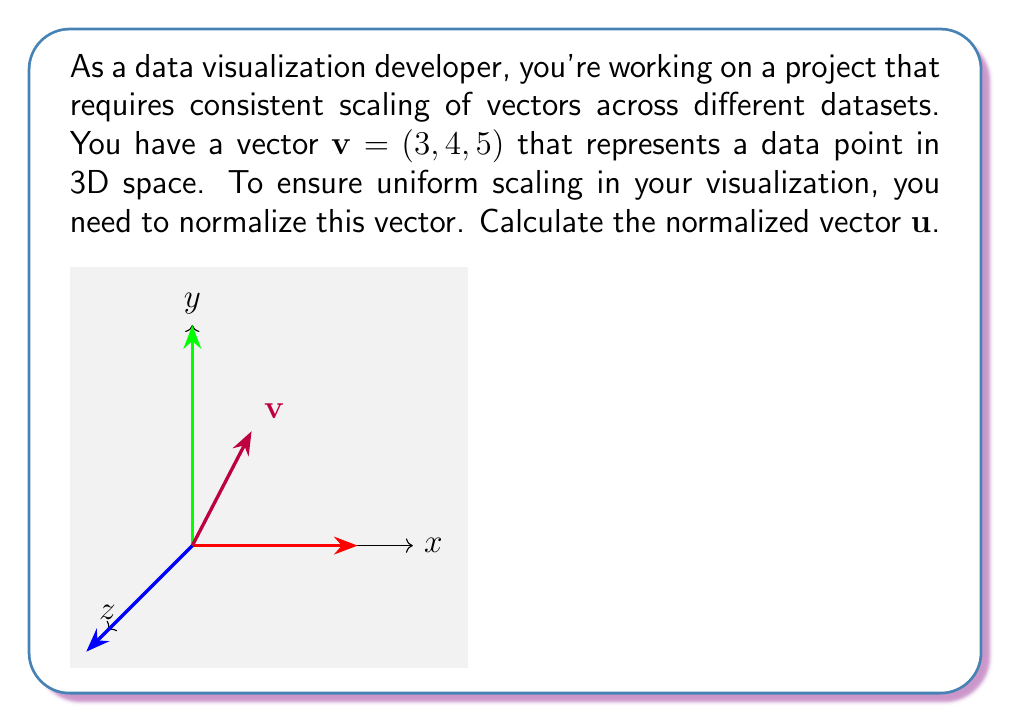Show me your answer to this math problem. To normalize a vector, we need to divide it by its magnitude. Let's break this down step-by-step:

1) First, calculate the magnitude of the vector $\mathbf{v}$. The magnitude is given by the square root of the sum of the squares of its components:

   $$\|\mathbf{v}\| = \sqrt{3^2 + 4^2 + 5^2}$$

2) Simplify:
   $$\|\mathbf{v}\| = \sqrt{9 + 16 + 25} = \sqrt{50}$$

3) The normalized vector $\mathbf{u}$ is obtained by dividing each component of $\mathbf{v}$ by the magnitude:

   $$\mathbf{u} = \frac{\mathbf{v}}{\|\mathbf{v}\|} = \left(\frac{3}{\sqrt{50}}, \frac{4}{\sqrt{50}}, \frac{5}{\sqrt{50}}\right)$$

4) Simplify by factoring out $\frac{1}{\sqrt{50}}$:

   $$\mathbf{u} = \frac{1}{\sqrt{50}}(3, 4, 5)$$

5) To simplify further, we can rationalize the denominator:

   $$\mathbf{u} = \frac{1}{\sqrt{50}} \cdot \frac{\sqrt{50}}{\sqrt{50}}(3, 4, 5) = \frac{\sqrt{50}}{50}(3, 4, 5)$$

6) Simplify:

   $$\mathbf{u} = \frac{\sqrt{2}}{10}(3, 4, 5)$$

This normalized vector $\mathbf{u}$ has a magnitude of 1, which ensures consistent scaling in your data visualization.
Answer: $\mathbf{u} = \frac{\sqrt{2}}{10}(3, 4, 5)$ 